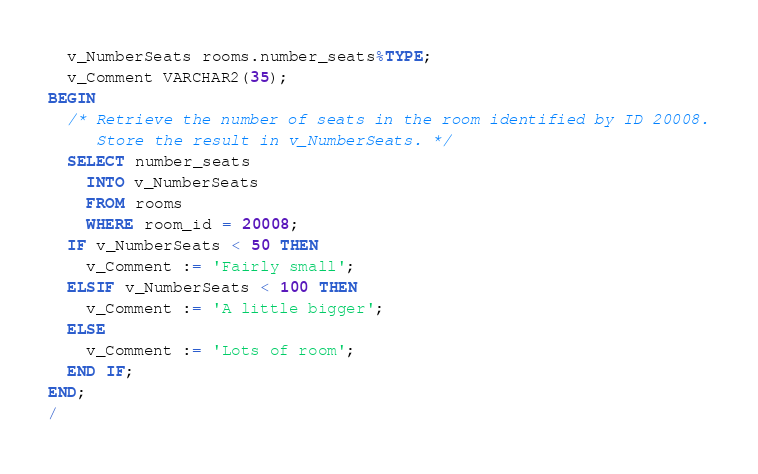<code> <loc_0><loc_0><loc_500><loc_500><_SQL_>  v_NumberSeats rooms.number_seats%TYPE;
  v_Comment VARCHAR2(35);
BEGIN
  /* Retrieve the number of seats in the room identified by ID 20008.
     Store the result in v_NumberSeats. */
  SELECT number_seats
    INTO v_NumberSeats
    FROM rooms
    WHERE room_id = 20008;
  IF v_NumberSeats < 50 THEN
    v_Comment := 'Fairly small';
  ELSIF v_NumberSeats < 100 THEN
    v_Comment := 'A little bigger';
  ELSE
    v_Comment := 'Lots of room';
  END IF;
END;
/
</code> 